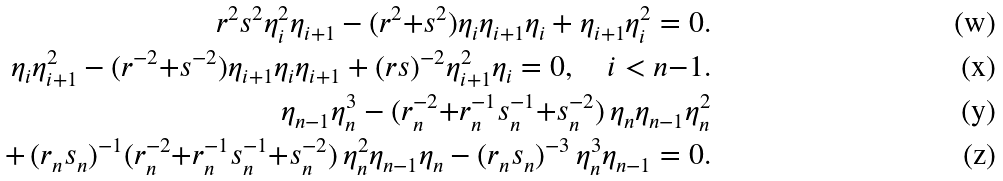Convert formula to latex. <formula><loc_0><loc_0><loc_500><loc_500>r ^ { 2 } s ^ { 2 } \eta _ { i } ^ { 2 } \eta _ { i + 1 } - ( r ^ { 2 } { + } s ^ { 2 } ) \eta _ { i } \eta _ { i + 1 } \eta _ { i } + \eta _ { i + 1 } \eta _ { i } ^ { 2 } = 0 . \\ \eta _ { i } \eta _ { i + 1 } ^ { 2 } - ( r ^ { - 2 } { + } s ^ { - 2 } ) \eta _ { i + 1 } \eta _ { i } \eta _ { i + 1 } + ( r s ) ^ { - 2 } \eta _ { i + 1 } ^ { 2 } \eta _ { i } = 0 , \quad i < n { - } 1 . \\ \eta _ { n - 1 } \eta _ { n } ^ { 3 } - ( r _ { n } ^ { - 2 } { + } r _ { n } ^ { - 1 } s _ { n } ^ { - 1 } { + } s _ { n } ^ { - 2 } ) \, \eta _ { n } \eta _ { n - 1 } \eta _ { n } ^ { 2 } \\ + \, ( r _ { n } s _ { n } ) ^ { - 1 } ( r _ { n } ^ { - 2 } { + } r _ { n } ^ { - 1 } s _ { n } ^ { - 1 } { + } s _ { n } ^ { - 2 } ) \, \eta _ { n } ^ { 2 } \eta _ { n - 1 } \eta _ { n } - ( r _ { n } s _ { n } ) ^ { - 3 } \, \eta _ { n } ^ { 3 } \eta _ { n - 1 } = 0 .</formula> 